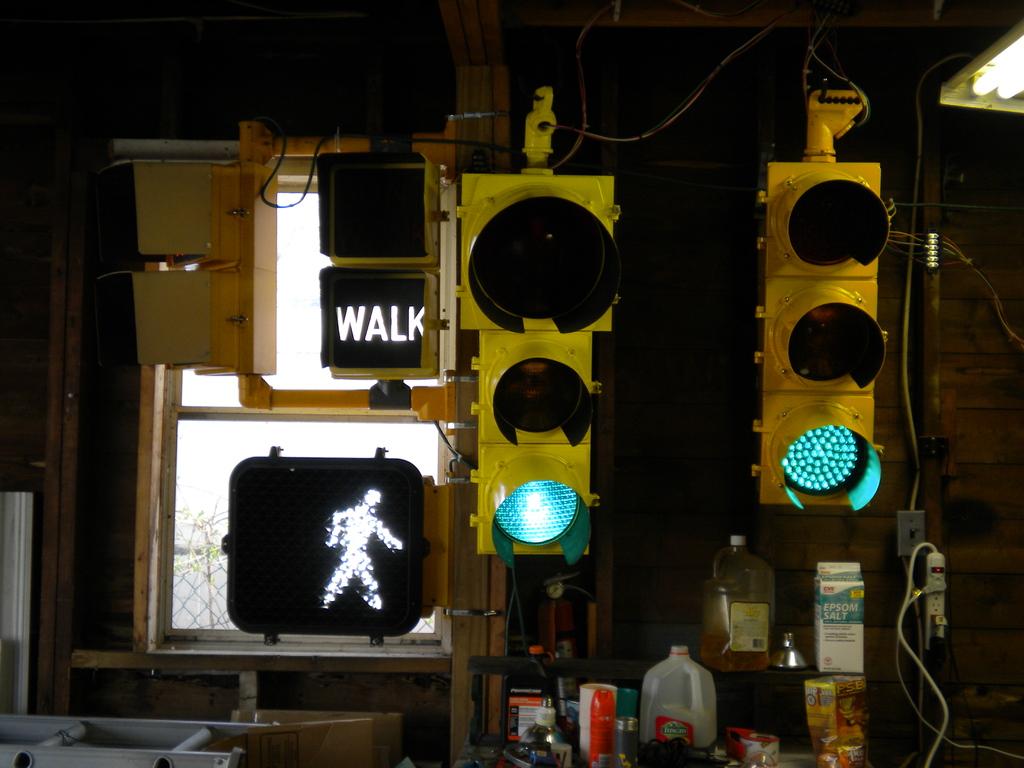What is the sign telling the pedestrian to do?
Your response must be concise. Walk. What kind of salt is on the container?
Provide a succinct answer. Epsom. 